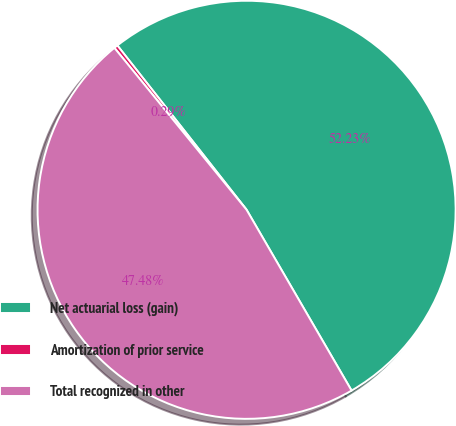Convert chart. <chart><loc_0><loc_0><loc_500><loc_500><pie_chart><fcel>Net actuarial loss (gain)<fcel>Amortization of prior service<fcel>Total recognized in other<nl><fcel>52.23%<fcel>0.29%<fcel>47.48%<nl></chart> 